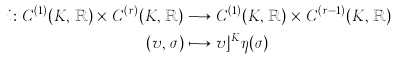<formula> <loc_0><loc_0><loc_500><loc_500>i \colon C ^ { ( 1 ) } ( K , \, \mathbb { R } ) \times C ^ { ( r ) } ( K , \, \mathbb { R } ) & \longrightarrow C ^ { ( 1 ) } ( K , \, \mathbb { R } ) \times C ^ { ( r - 1 ) } ( K , \, \mathbb { R } ) \\ ( v , \, \sigma ) & \longmapsto v \rfloor ^ { K } \eta ( \sigma )</formula> 